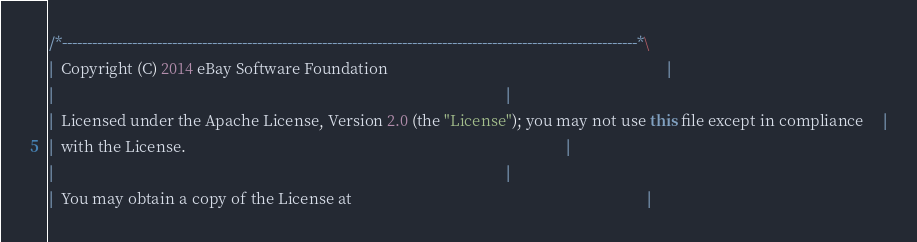<code> <loc_0><loc_0><loc_500><loc_500><_Java_>/*-------------------------------------------------------------------------------------------------------------------*\
|  Copyright (C) 2014 eBay Software Foundation                                                                        |
|                                                                                                                     |
|  Licensed under the Apache License, Version 2.0 (the "License"); you may not use this file except in compliance     |
|  with the License.                                                                                                  |
|                                                                                                                     |
|  You may obtain a copy of the License at                                                                            |</code> 